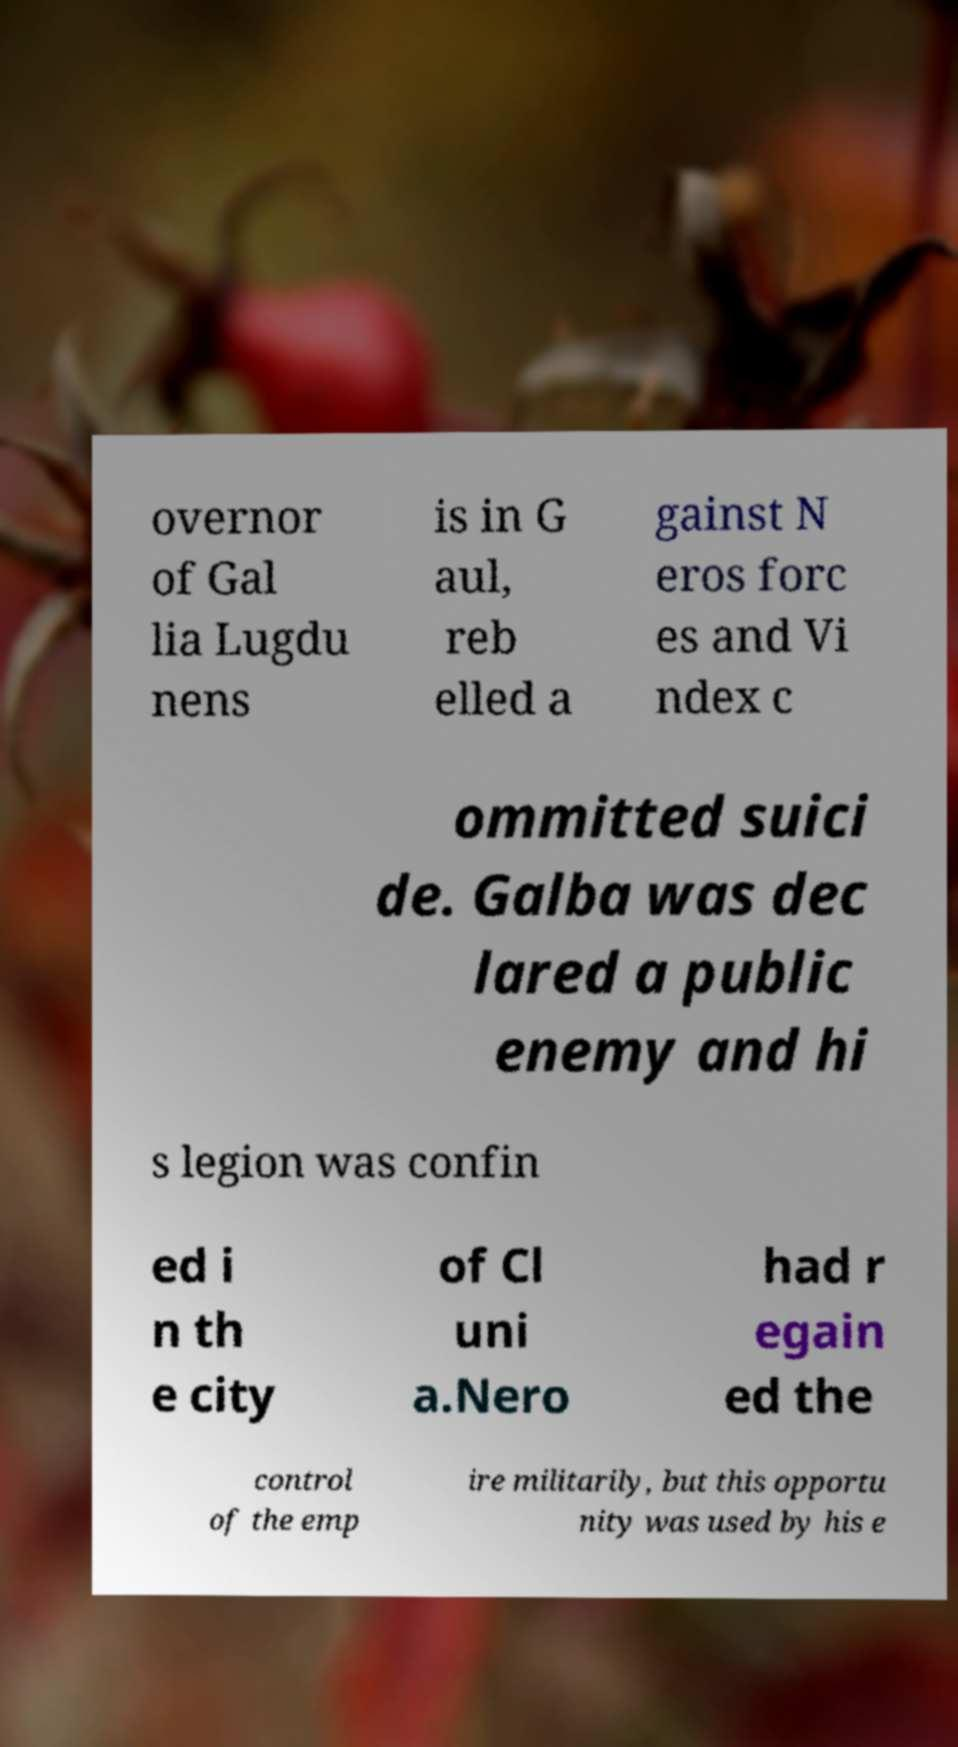Could you assist in decoding the text presented in this image and type it out clearly? overnor of Gal lia Lugdu nens is in G aul, reb elled a gainst N eros forc es and Vi ndex c ommitted suici de. Galba was dec lared a public enemy and hi s legion was confin ed i n th e city of Cl uni a.Nero had r egain ed the control of the emp ire militarily, but this opportu nity was used by his e 